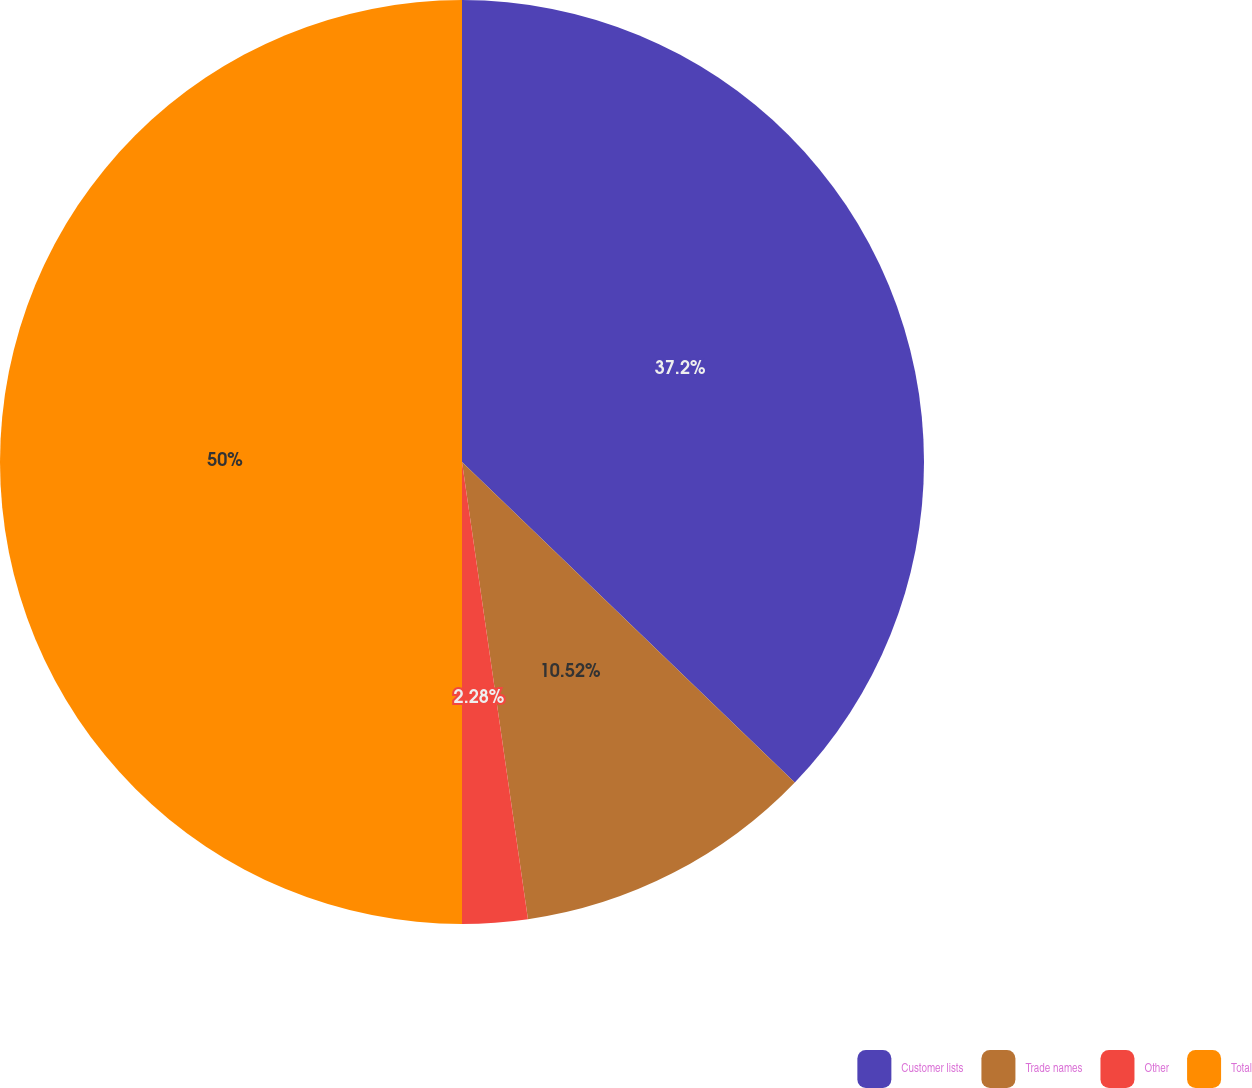Convert chart to OTSL. <chart><loc_0><loc_0><loc_500><loc_500><pie_chart><fcel>Customer lists<fcel>Trade names<fcel>Other<fcel>Total<nl><fcel>37.2%<fcel>10.52%<fcel>2.28%<fcel>50.0%<nl></chart> 